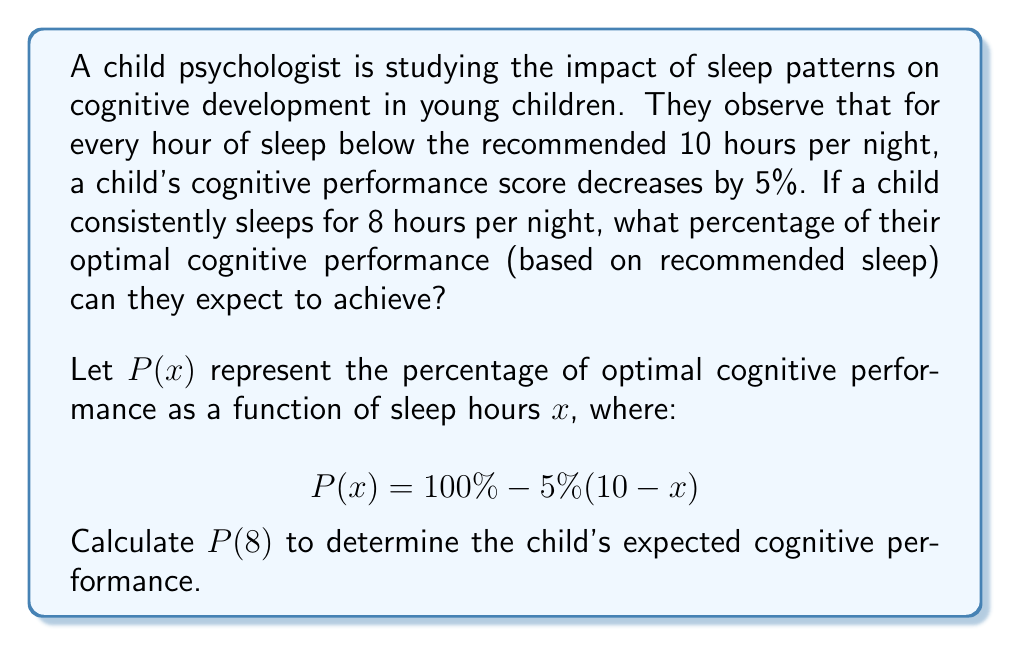Show me your answer to this math problem. To solve this problem, we'll follow these steps:

1. Understand the given function:
   $P(x) = 100\% - 5\%(10-x)$
   Where $x$ is the number of sleep hours, and $P(x)$ is the percentage of optimal cognitive performance.

2. We need to calculate $P(8)$, as the child sleeps for 8 hours per night.

3. Substitute $x = 8$ into the function:
   $P(8) = 100\% - 5\%(10-8)$

4. Simplify the expression inside the parentheses:
   $P(8) = 100\% - 5\%(2)$

5. Calculate 5% of 2:
   $5\% \times 2 = 0.05 \times 2 = 0.1 = 10\%$

6. Subtract this from 100%:
   $P(8) = 100\% - 10\% = 90\%$

Therefore, the child can expect to achieve 90% of their optimal cognitive performance when consistently sleeping for 8 hours per night.
Answer: 90% 